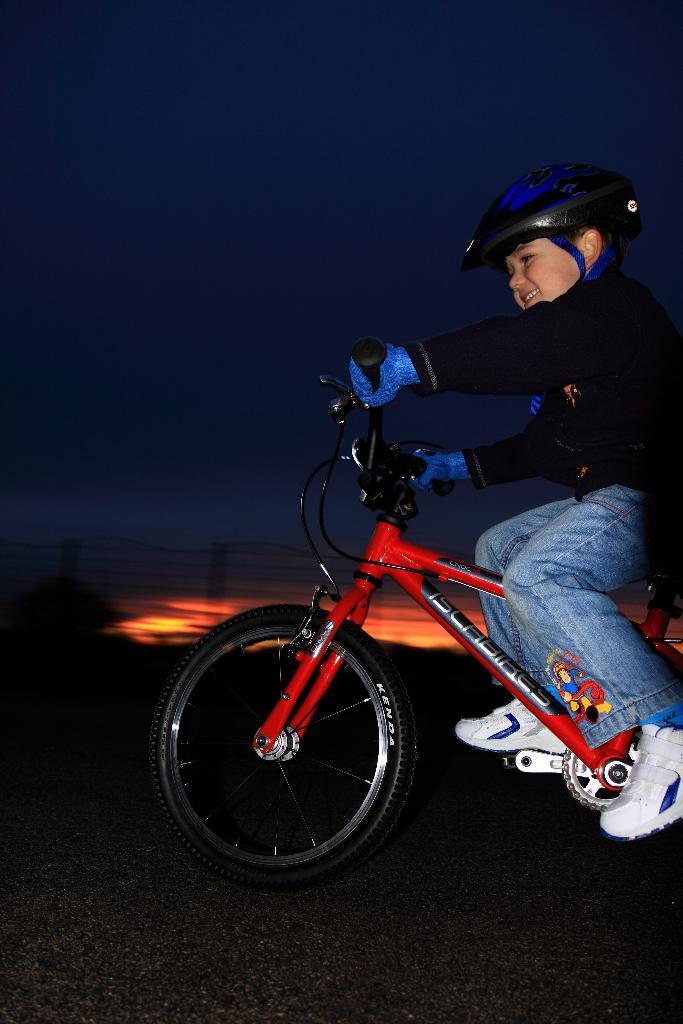What is the main subject of the image? The main subject of the image is a boy. What is the boy doing in the image? The boy is riding a bicycle. What can be observed about the background of the image? The background of the image is dark. What type of tax can be seen being paid by the boy in the image? There is no indication of any tax being paid in the image; the boy is simply riding a bicycle. How deep is the hole that the boy is riding his bicycle into in the image? There is no hole present in the image; the boy is riding his bicycle on a flat surface. 